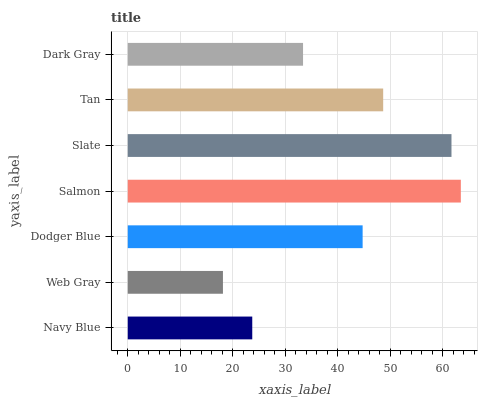Is Web Gray the minimum?
Answer yes or no. Yes. Is Salmon the maximum?
Answer yes or no. Yes. Is Dodger Blue the minimum?
Answer yes or no. No. Is Dodger Blue the maximum?
Answer yes or no. No. Is Dodger Blue greater than Web Gray?
Answer yes or no. Yes. Is Web Gray less than Dodger Blue?
Answer yes or no. Yes. Is Web Gray greater than Dodger Blue?
Answer yes or no. No. Is Dodger Blue less than Web Gray?
Answer yes or no. No. Is Dodger Blue the high median?
Answer yes or no. Yes. Is Dodger Blue the low median?
Answer yes or no. Yes. Is Dark Gray the high median?
Answer yes or no. No. Is Navy Blue the low median?
Answer yes or no. No. 